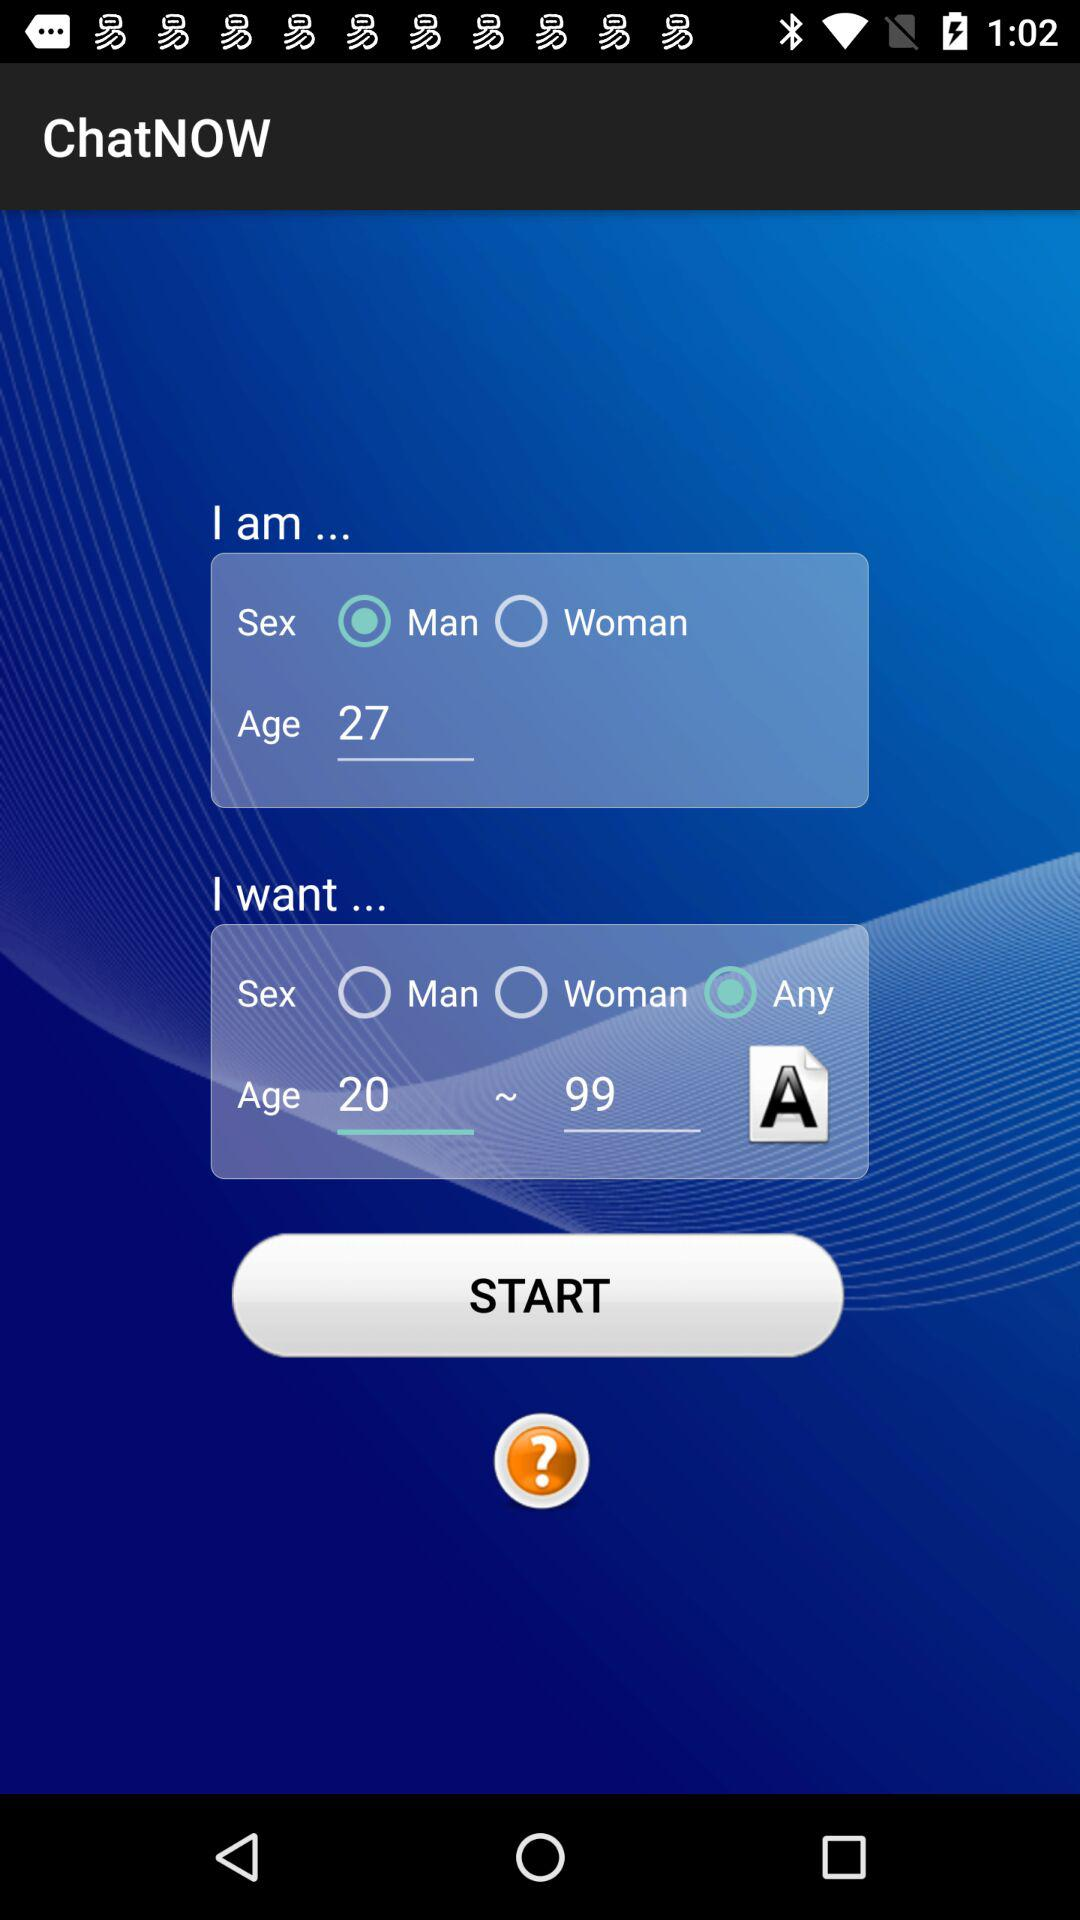Which option is selected in "I want"? The selected option is "Any". 